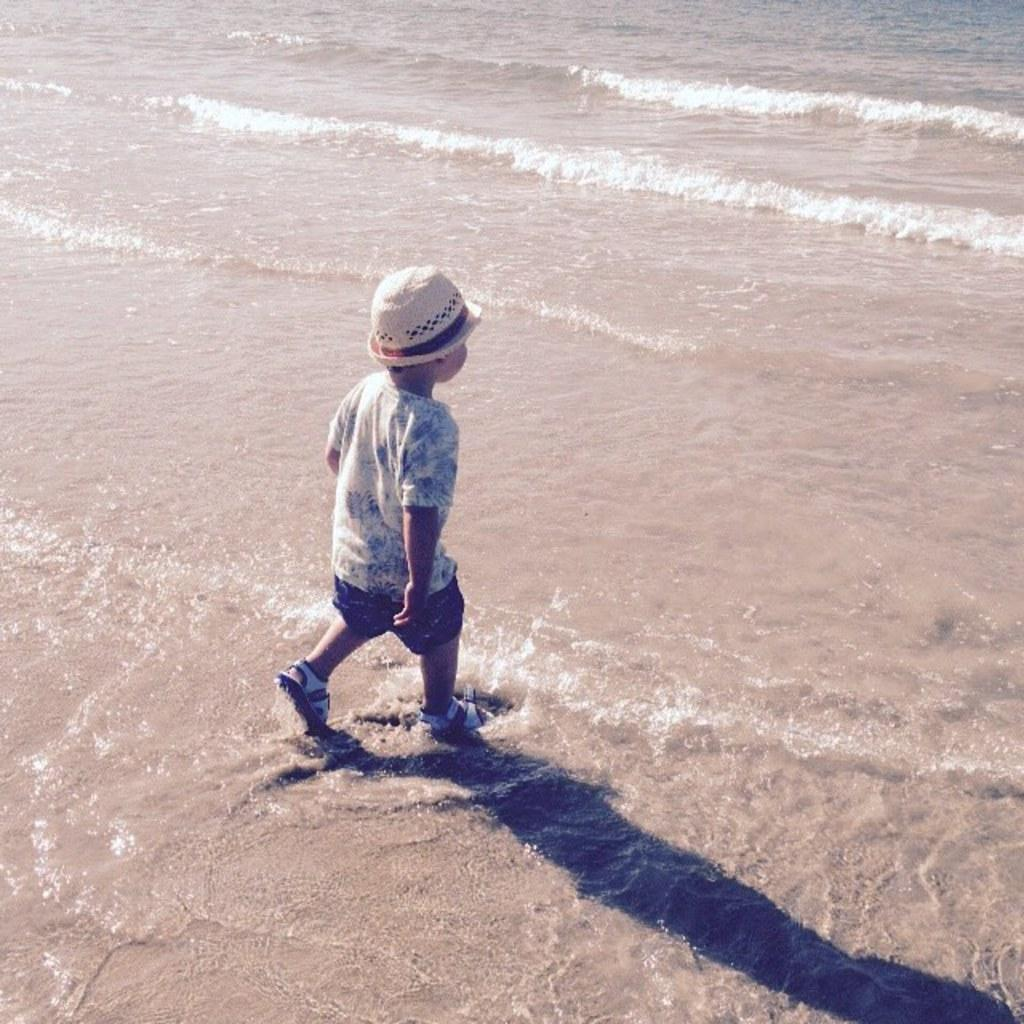What is the main subject of the image? The main subject of the image is a kid. What is the kid doing in the image? The kid is running on the ground. What can be seen on the ground in the image? There is water on the ground. What type of location might the image depict? The setting appears to be a beach. What flavor of pancake is the kid holding in the image? There is no pancake present in the image, so it is not possible to determine the flavor of any pancake. 